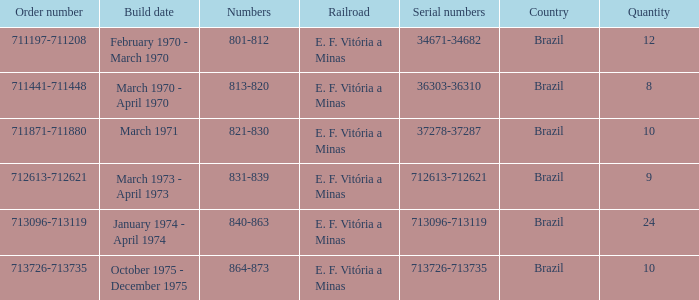The numbers 801-812 are in which country? Brazil. 